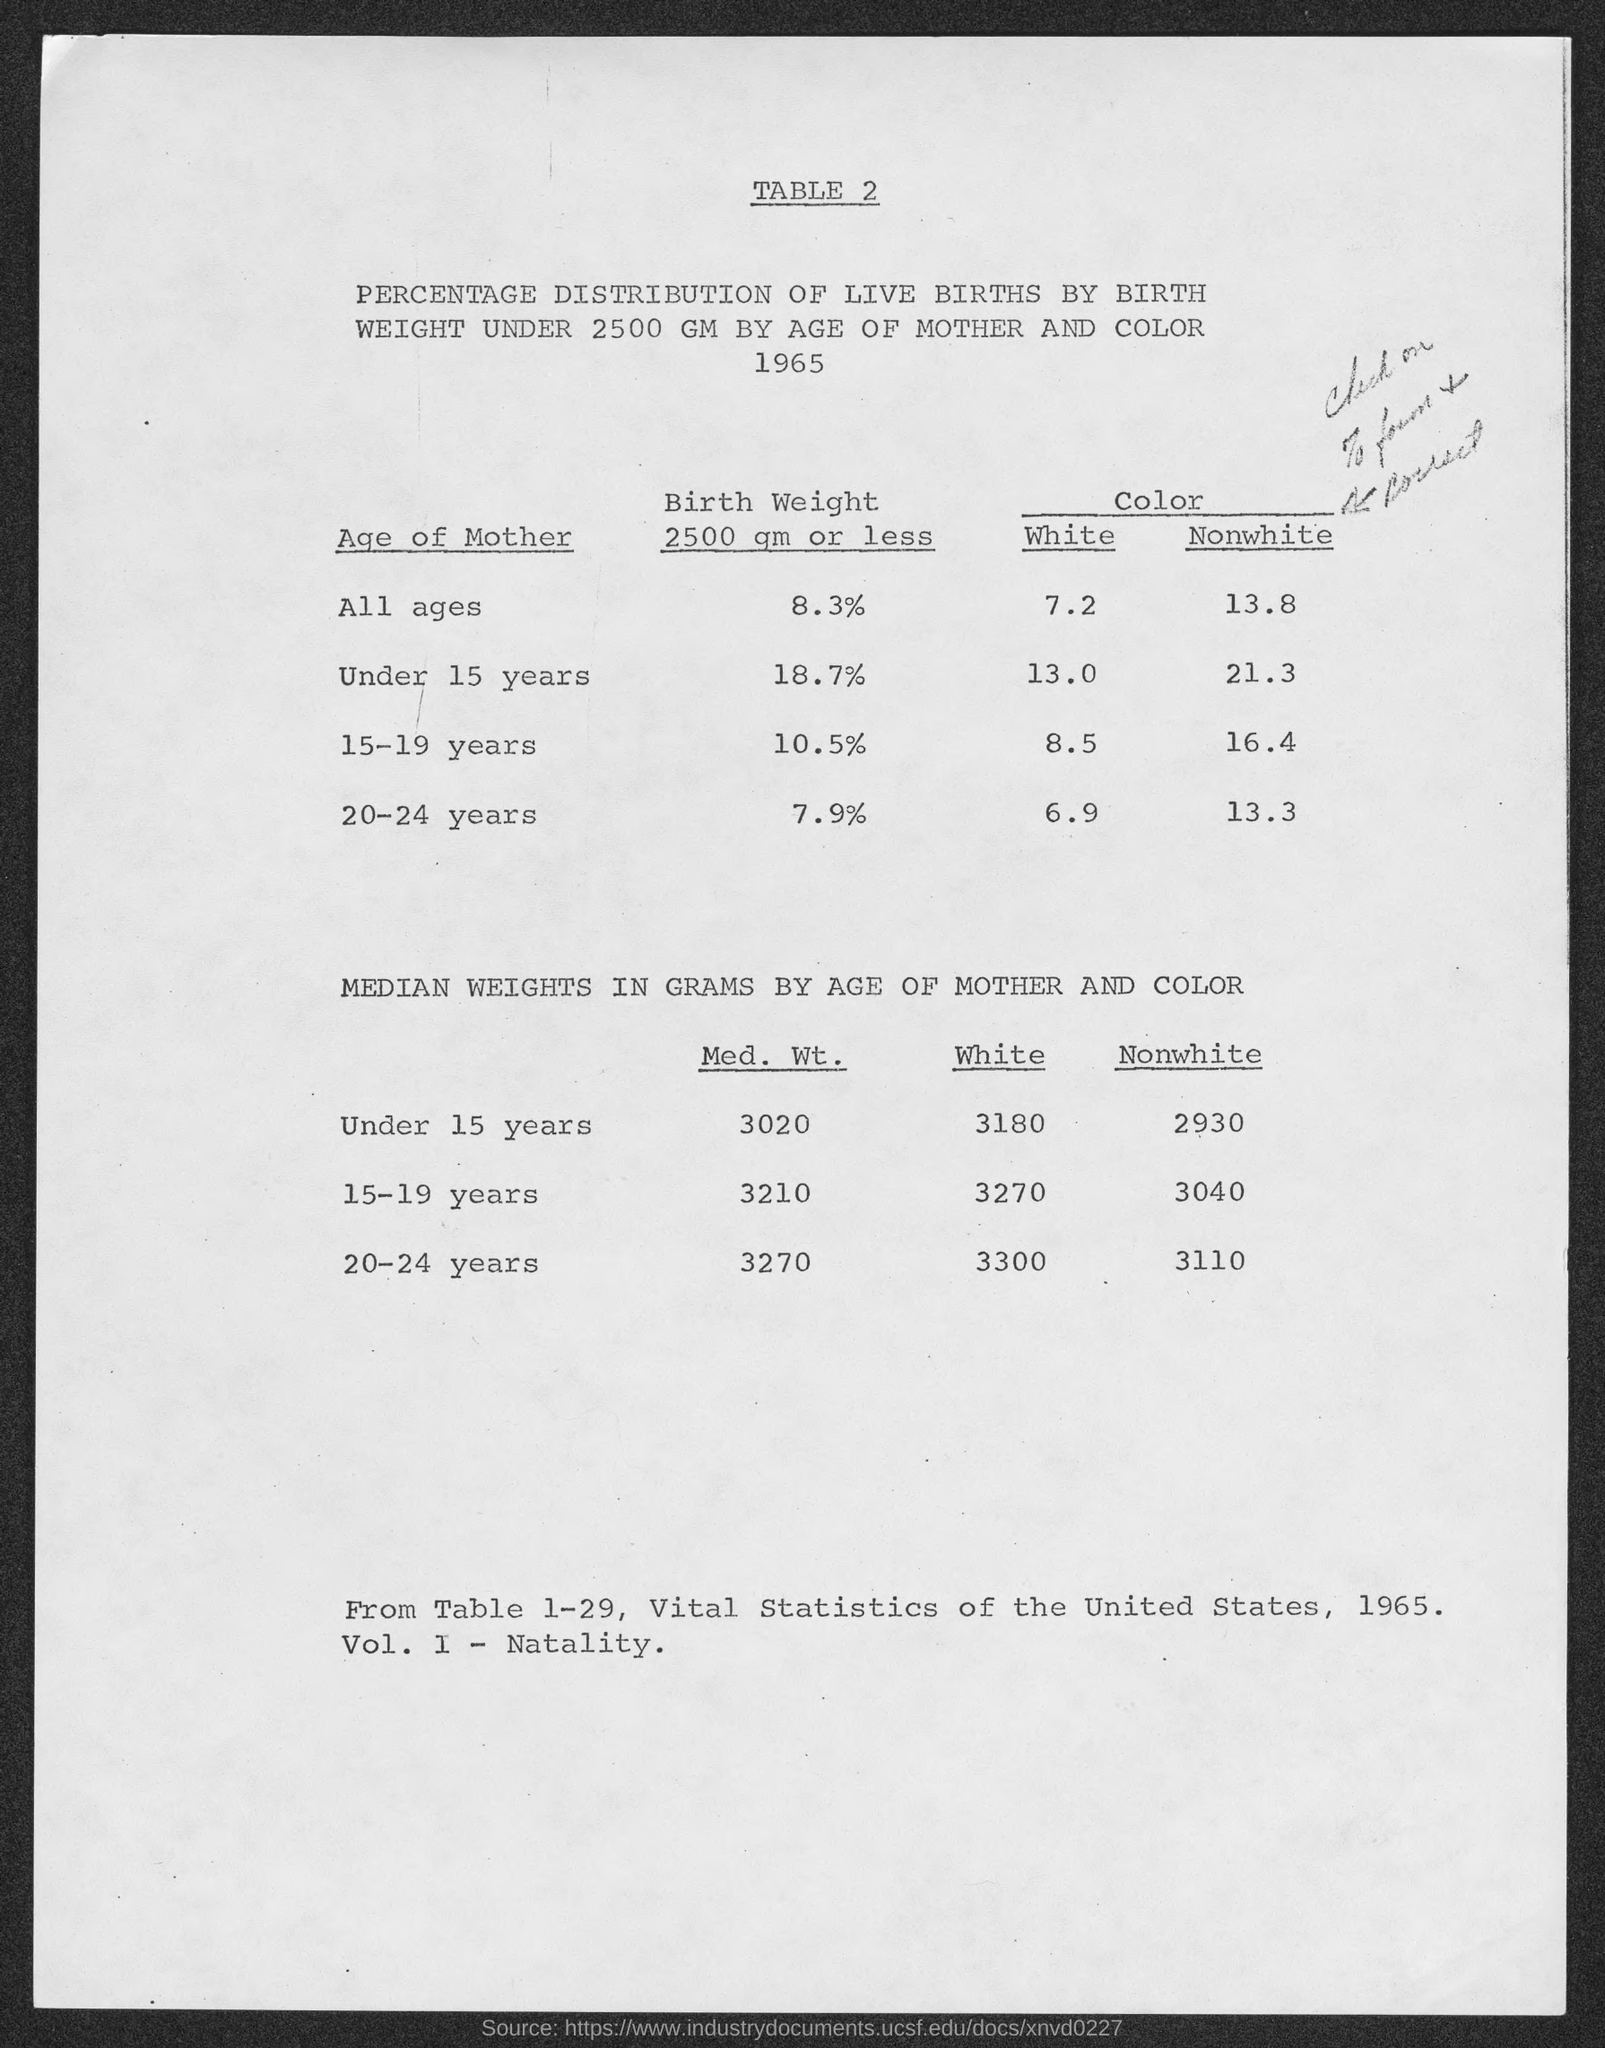Give some essential details in this illustration. The table number is 2. It is referred to as 'table 2'. According to data, the birth weight of mothers of all ages is 8.3%. 